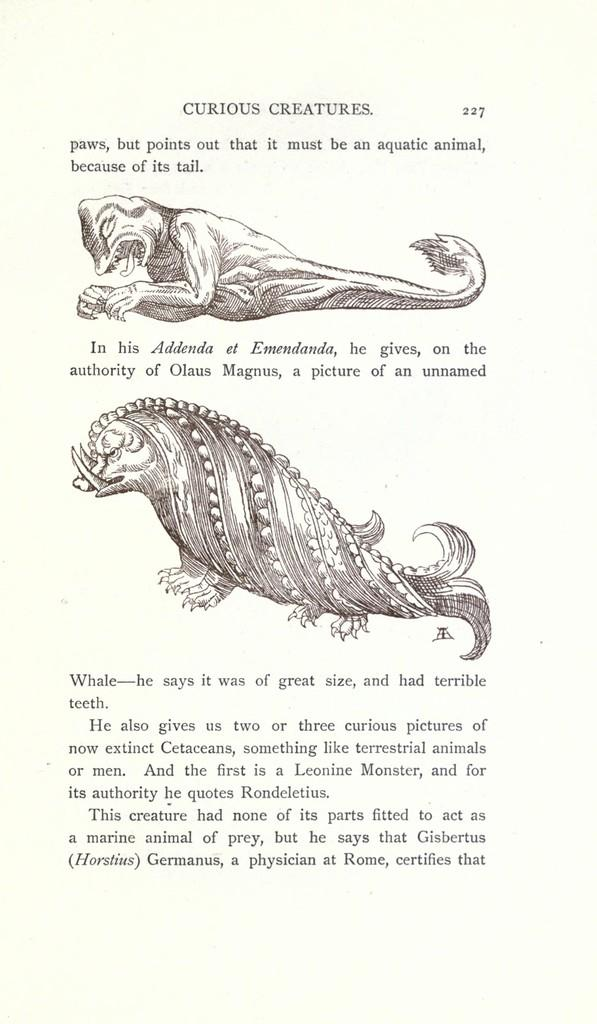What is depicted in the image? There is a sketch of animals in the image. Can you describe what is written on the image? Unfortunately, the specific content of the writing cannot be determined from the provided facts. How many animals are included in the sketch? The number of animals in the sketch cannot be determined from the provided facts. What color is the fear in the image? There is no fear present in the image, as it features a sketch of animals and writing. What time of day is depicted in the image? The time of day cannot be determined from the provided facts, as the image only contains a sketch of animals and writing. 